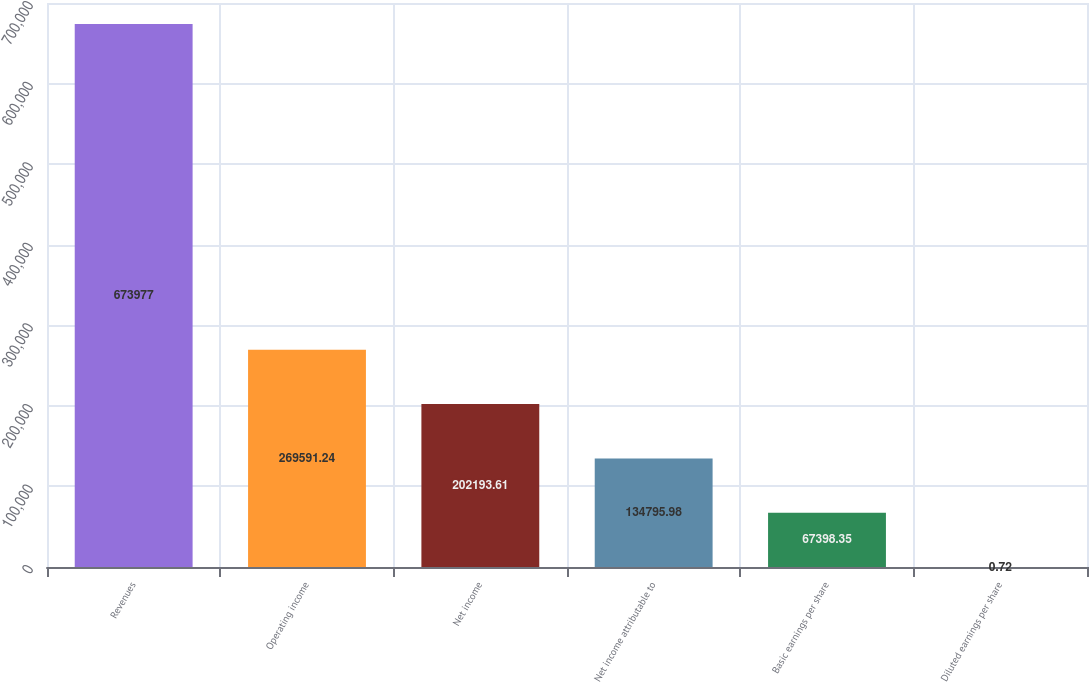Convert chart. <chart><loc_0><loc_0><loc_500><loc_500><bar_chart><fcel>Revenues<fcel>Operating income<fcel>Net income<fcel>Net income attributable to<fcel>Basic earnings per share<fcel>Diluted earnings per share<nl><fcel>673977<fcel>269591<fcel>202194<fcel>134796<fcel>67398.4<fcel>0.72<nl></chart> 